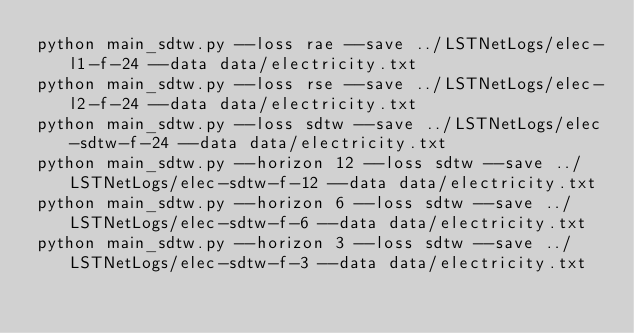Convert code to text. <code><loc_0><loc_0><loc_500><loc_500><_Bash_>python main_sdtw.py --loss rae --save ../LSTNetLogs/elec-l1-f-24 --data data/electricity.txt
python main_sdtw.py --loss rse --save ../LSTNetLogs/elec-l2-f-24 --data data/electricity.txt
python main_sdtw.py --loss sdtw --save ../LSTNetLogs/elec-sdtw-f-24 --data data/electricity.txt
python main_sdtw.py --horizon 12 --loss sdtw --save ../LSTNetLogs/elec-sdtw-f-12 --data data/electricity.txt
python main_sdtw.py --horizon 6 --loss sdtw --save ../LSTNetLogs/elec-sdtw-f-6 --data data/electricity.txt
python main_sdtw.py --horizon 3 --loss sdtw --save ../LSTNetLogs/elec-sdtw-f-3 --data data/electricity.txt
</code> 